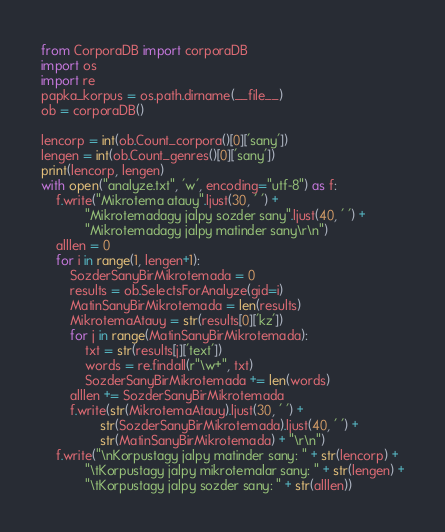<code> <loc_0><loc_0><loc_500><loc_500><_Python_>from CorporaDB import corporaDB
import os
import re
papka_korpus = os.path.dirname(__file__)
ob = corporaDB()

lencorp = int(ob.Count_corpora()[0]['sany'])
lengen = int(ob.Count_genres()[0]['sany'])
print(lencorp, lengen)
with open("analyze.txt", 'w', encoding="utf-8") as f:
    f.write("Mikrotema atauy".ljust(30, ' ') +
            "Mikrotemadagy jalpy sozder sany".ljust(40, ' ') +
            "Mikrotemadagy jalpy matinder sany\r\n")
    alllen = 0
    for i in range(1, lengen+1):
        SozderSanyBirMikrotemada = 0
        results = ob.SelectsForAnalyze(gid=i)
        MatinSanyBirMikrotemada = len(results)
        MikrotemaAtauy = str(results[0]['kz'])
        for j in range(MatinSanyBirMikrotemada):
            txt = str(results[j]['text'])
            words = re.findall(r"\w+", txt)
            SozderSanyBirMikrotemada += len(words)
        alllen += SozderSanyBirMikrotemada
        f.write(str(MikrotemaAtauy).ljust(30, ' ') +
                str(SozderSanyBirMikrotemada).ljust(40, ' ') +
                str(MatinSanyBirMikrotemada) + "\r\n")
    f.write("\nKorpustagy jalpy matinder sany: " + str(lencorp) +
            "\tKorpustagy jalpy mikrotemalar sany: " + str(lengen) +
            "\tKorpustagy jalpy sozder sany: " + str(alllen))</code> 